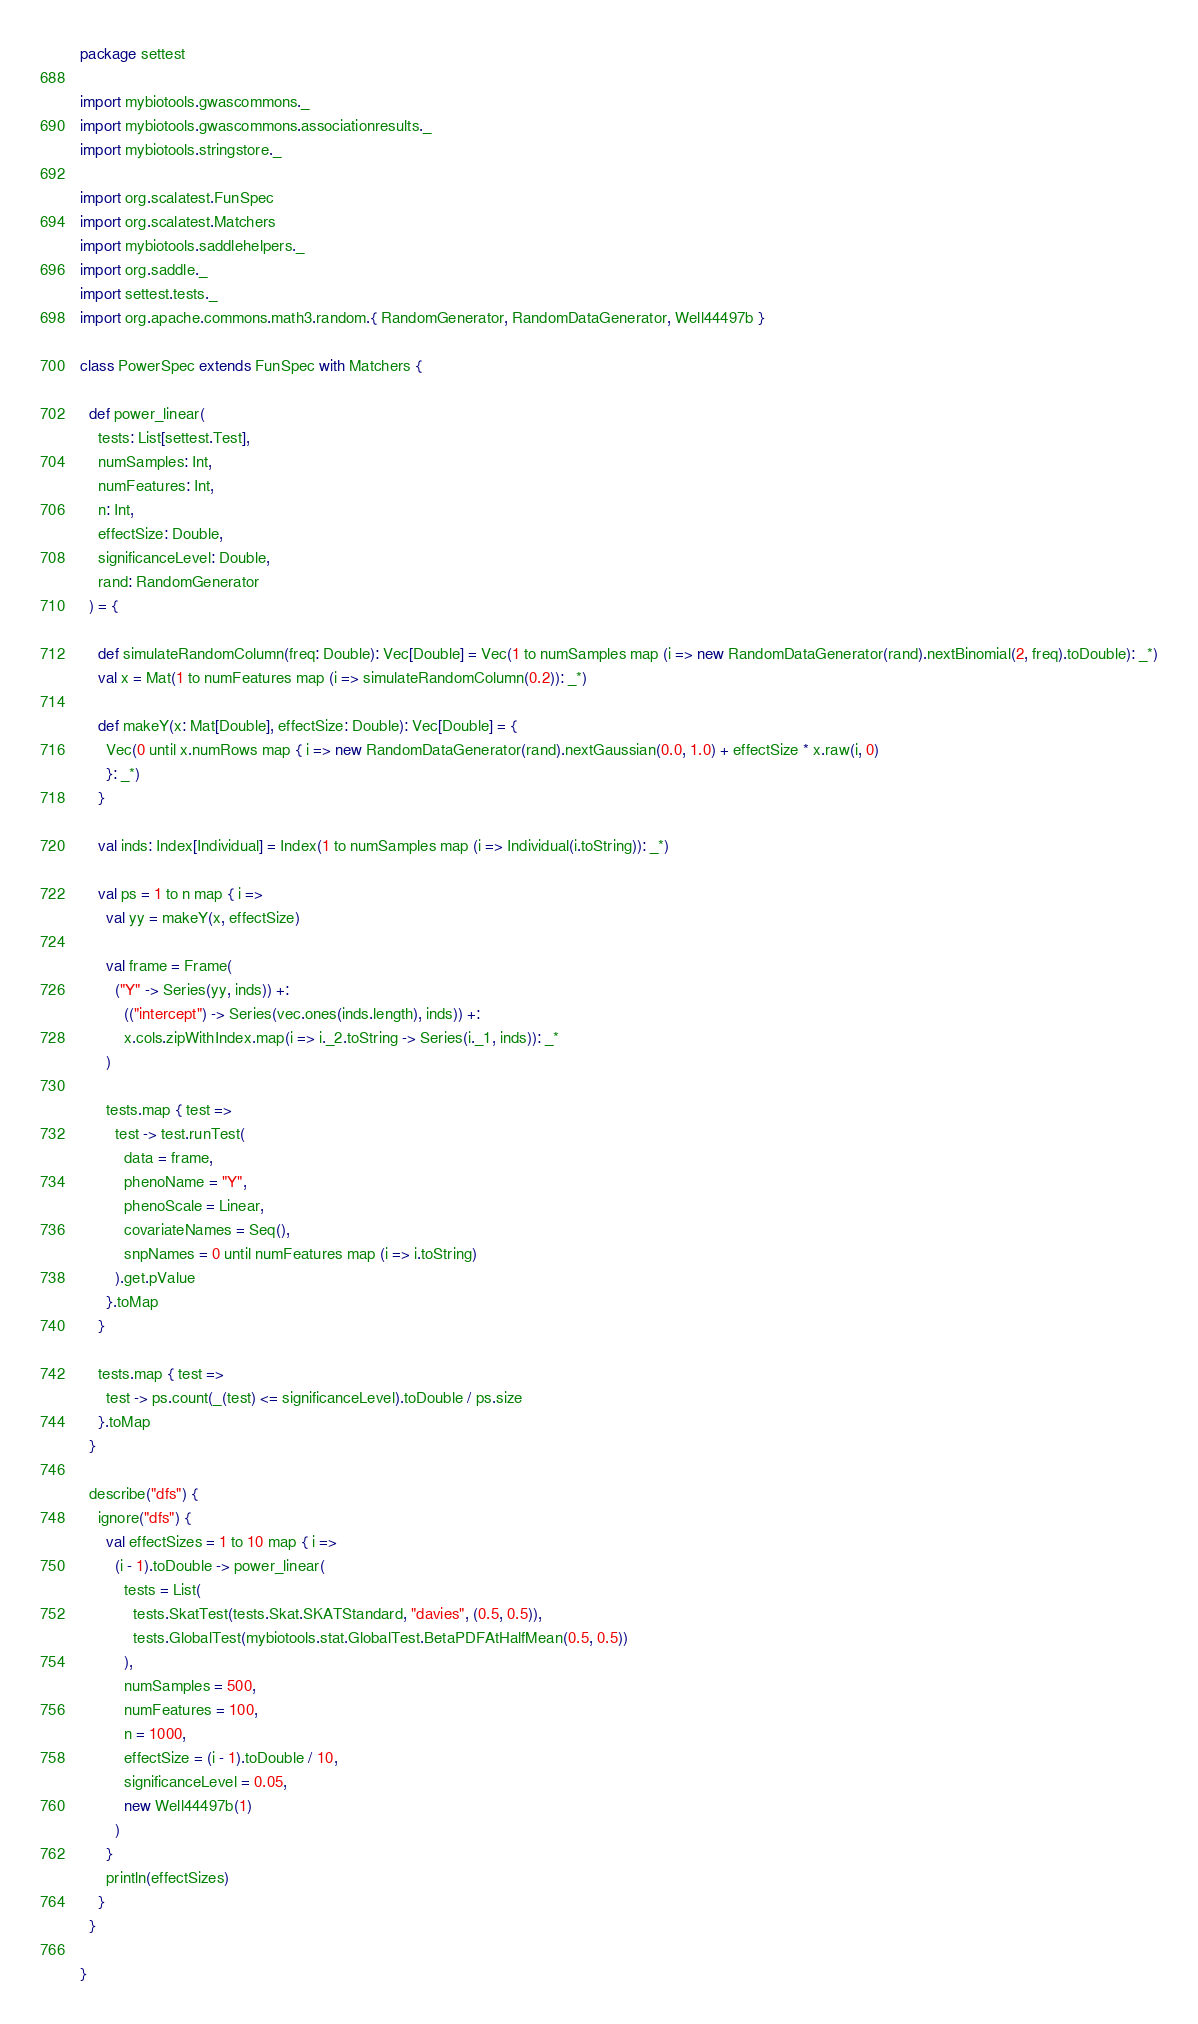Convert code to text. <code><loc_0><loc_0><loc_500><loc_500><_Scala_>package settest

import mybiotools.gwascommons._
import mybiotools.gwascommons.associationresults._
import mybiotools.stringstore._

import org.scalatest.FunSpec
import org.scalatest.Matchers
import mybiotools.saddlehelpers._
import org.saddle._
import settest.tests._
import org.apache.commons.math3.random.{ RandomGenerator, RandomDataGenerator, Well44497b }

class PowerSpec extends FunSpec with Matchers {

  def power_linear(
    tests: List[settest.Test],
    numSamples: Int,
    numFeatures: Int,
    n: Int,
    effectSize: Double,
    significanceLevel: Double,
    rand: RandomGenerator
  ) = {

    def simulateRandomColumn(freq: Double): Vec[Double] = Vec(1 to numSamples map (i => new RandomDataGenerator(rand).nextBinomial(2, freq).toDouble): _*)
    val x = Mat(1 to numFeatures map (i => simulateRandomColumn(0.2)): _*)

    def makeY(x: Mat[Double], effectSize: Double): Vec[Double] = {
      Vec(0 until x.numRows map { i => new RandomDataGenerator(rand).nextGaussian(0.0, 1.0) + effectSize * x.raw(i, 0)
      }: _*)
    }

    val inds: Index[Individual] = Index(1 to numSamples map (i => Individual(i.toString)): _*)

    val ps = 1 to n map { i =>
      val yy = makeY(x, effectSize)

      val frame = Frame(
        ("Y" -> Series(yy, inds)) +:
          (("intercept") -> Series(vec.ones(inds.length), inds)) +:
          x.cols.zipWithIndex.map(i => i._2.toString -> Series(i._1, inds)): _*
      )

      tests.map { test =>
        test -> test.runTest(
          data = frame,
          phenoName = "Y",
          phenoScale = Linear,
          covariateNames = Seq(),
          snpNames = 0 until numFeatures map (i => i.toString)
        ).get.pValue
      }.toMap
    }

    tests.map { test =>
      test -> ps.count(_(test) <= significanceLevel).toDouble / ps.size
    }.toMap
  }

  describe("dfs") {
    ignore("dfs") {
      val effectSizes = 1 to 10 map { i =>
        (i - 1).toDouble -> power_linear(
          tests = List(
            tests.SkatTest(tests.Skat.SKATStandard, "davies", (0.5, 0.5)),
            tests.GlobalTest(mybiotools.stat.GlobalTest.BetaPDFAtHalfMean(0.5, 0.5))
          ),
          numSamples = 500,
          numFeatures = 100,
          n = 1000,
          effectSize = (i - 1).toDouble / 10,
          significanceLevel = 0.05,
          new Well44497b(1)
        )
      }
      println(effectSizes)
    }
  }

}</code> 